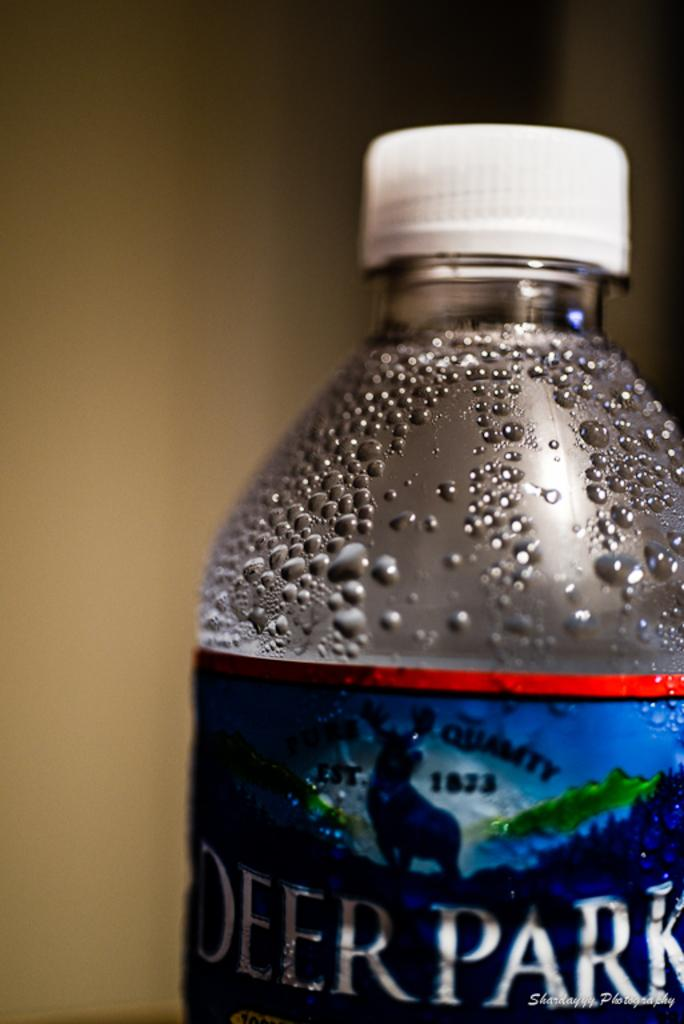Provide a one-sentence caption for the provided image. A bottle of Deer Park water with condensation forming at the top. 